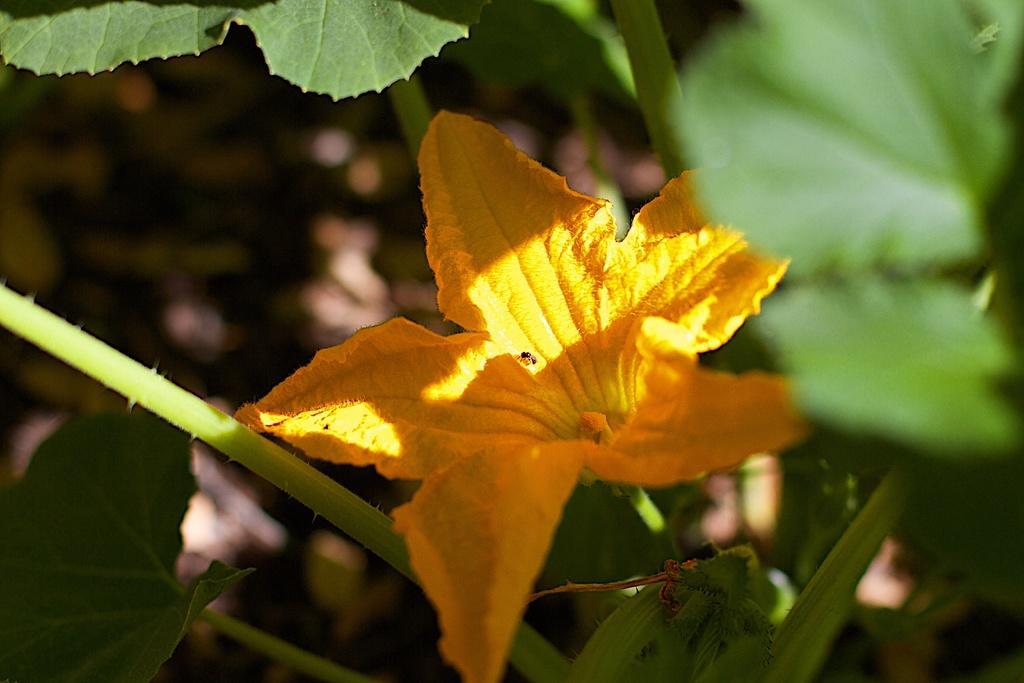Could you give a brief overview of what you see in this image? In the center of the picture there is a flower. In this picture we can see leaves and stems of a plant. The background is blurred. 